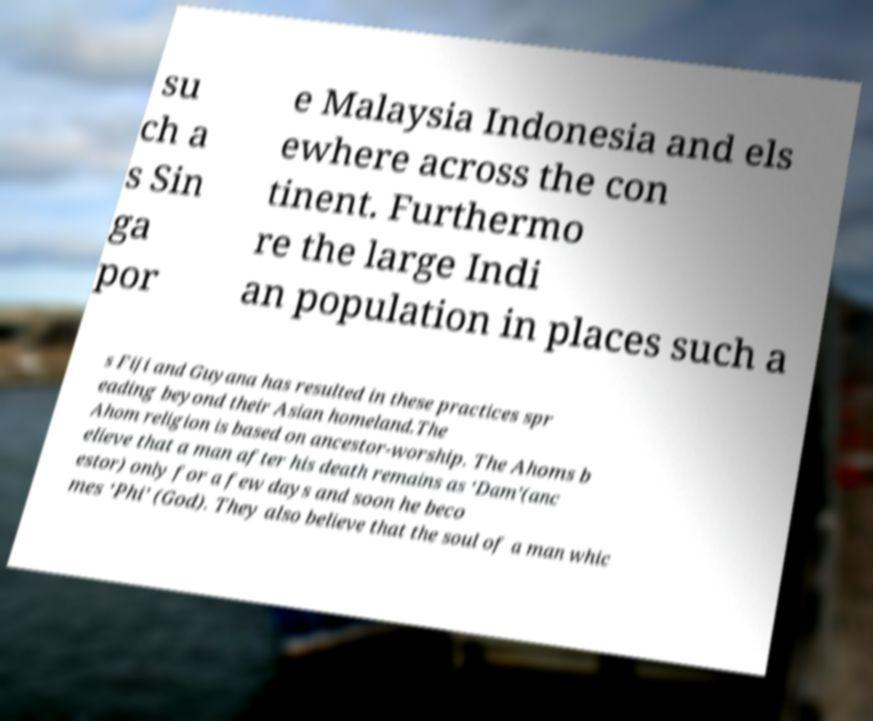What messages or text are displayed in this image? I need them in a readable, typed format. su ch a s Sin ga por e Malaysia Indonesia and els ewhere across the con tinent. Furthermo re the large Indi an population in places such a s Fiji and Guyana has resulted in these practices spr eading beyond their Asian homeland.The Ahom religion is based on ancestor-worship. The Ahoms b elieve that a man after his death remains as ‘Dam’(anc estor) only for a few days and soon he beco mes ‘Phi’ (God). They also believe that the soul of a man whic 